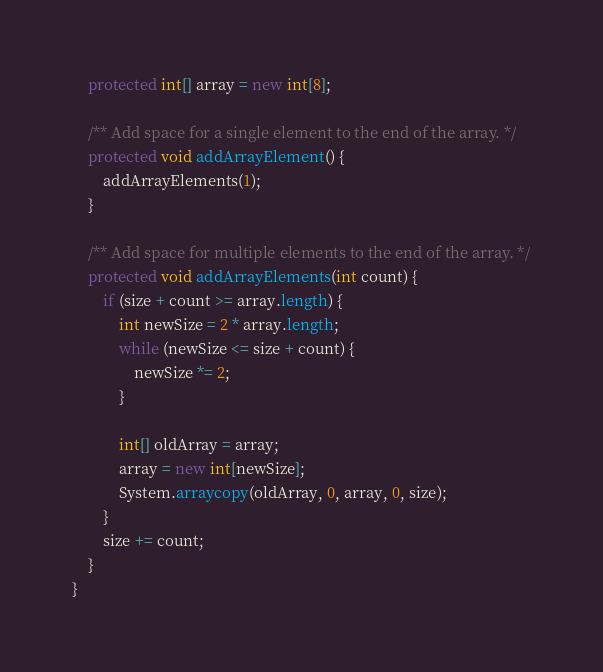<code> <loc_0><loc_0><loc_500><loc_500><_Java_>	protected int[] array = new int[8];

	/** Add space for a single element to the end of the array. */
	protected void addArrayElement() {
		addArrayElements(1);
	}

	/** Add space for multiple elements to the end of the array. */
	protected void addArrayElements(int count) {
		if (size + count >= array.length) {
			int newSize = 2 * array.length;
			while (newSize <= size + count) {
				newSize *= 2;
			}

			int[] oldArray = array;
			array = new int[newSize];
			System.arraycopy(oldArray, 0, array, 0, size);
		}
		size += count;
	}
}</code> 